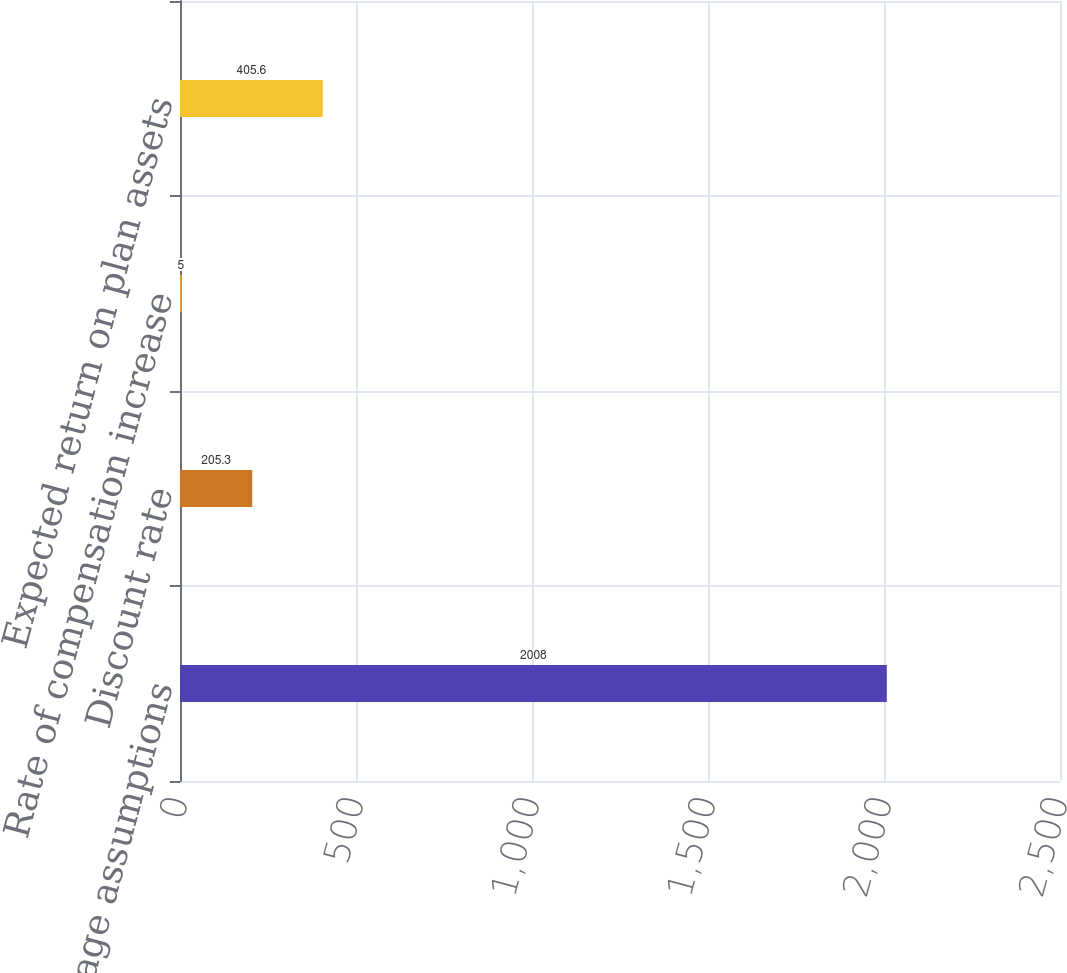Convert chart to OTSL. <chart><loc_0><loc_0><loc_500><loc_500><bar_chart><fcel>Weighted-average assumptions<fcel>Discount rate<fcel>Rate of compensation increase<fcel>Expected return on plan assets<nl><fcel>2008<fcel>205.3<fcel>5<fcel>405.6<nl></chart> 